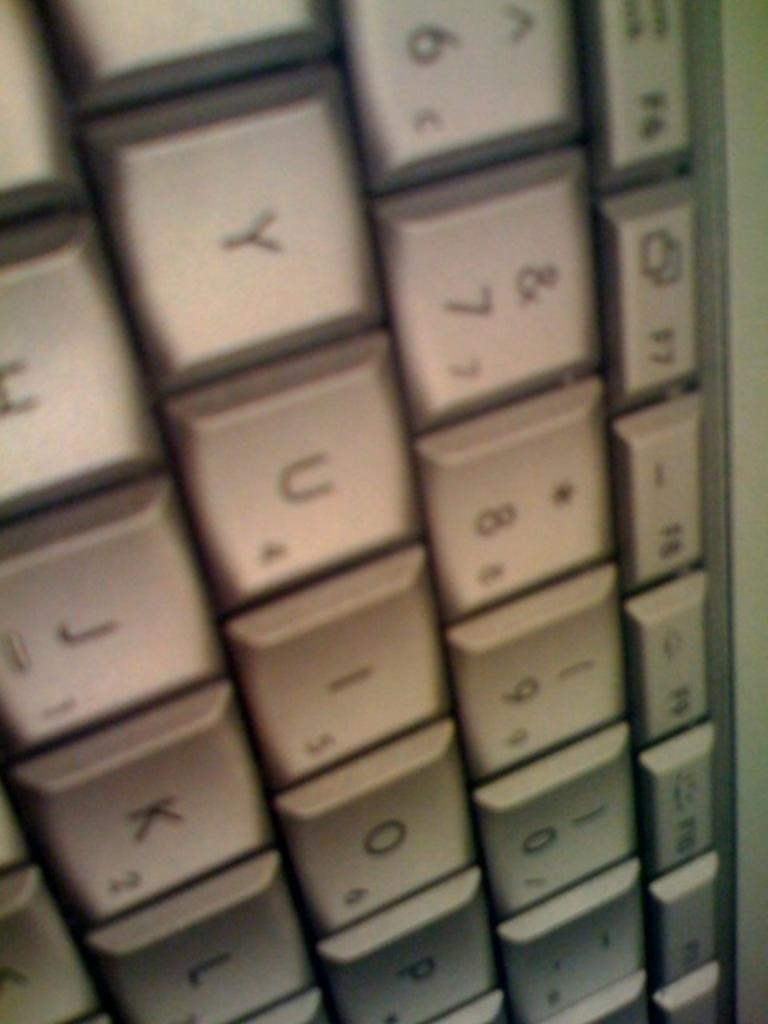<image>
Present a compact description of the photo's key features. White keyboard keys with the letters "UIO" in the middle. 